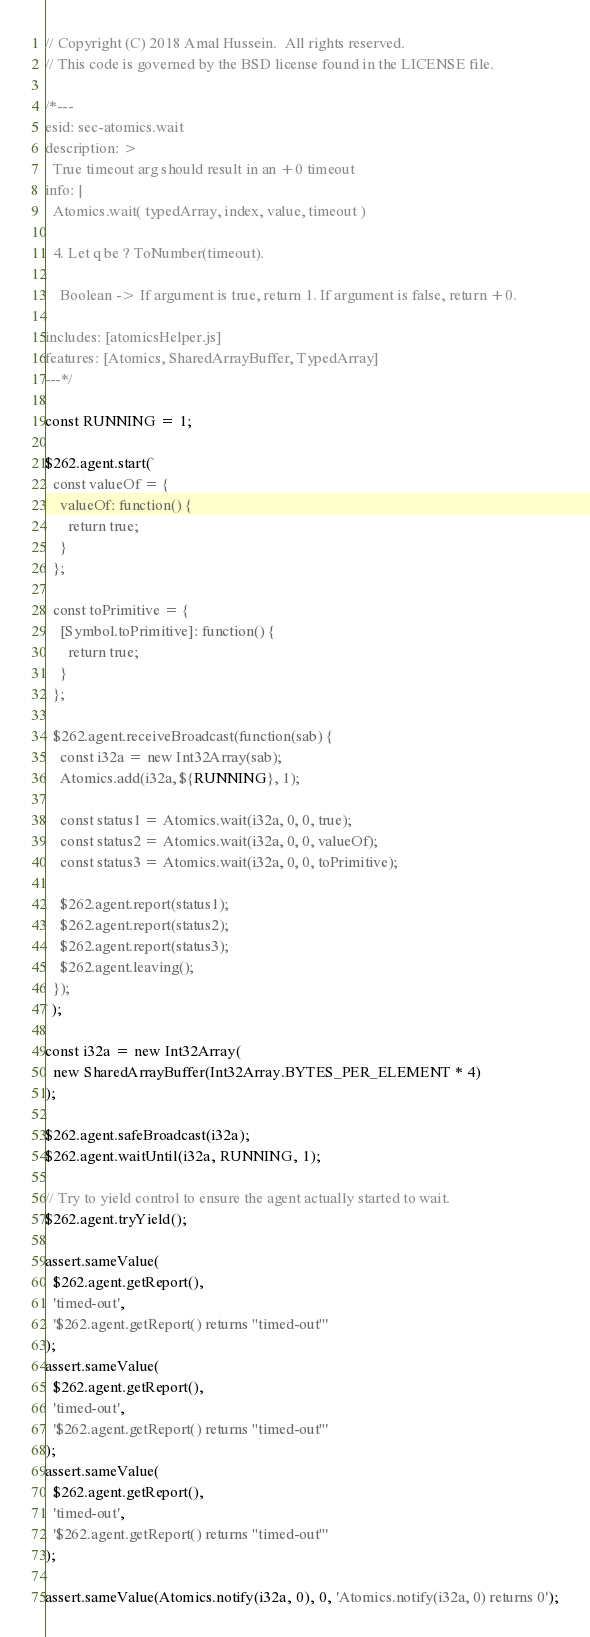Convert code to text. <code><loc_0><loc_0><loc_500><loc_500><_JavaScript_>// Copyright (C) 2018 Amal Hussein.  All rights reserved.
// This code is governed by the BSD license found in the LICENSE file.

/*---
esid: sec-atomics.wait
description: >
  True timeout arg should result in an +0 timeout
info: |
  Atomics.wait( typedArray, index, value, timeout )

  4. Let q be ? ToNumber(timeout).

    Boolean -> If argument is true, return 1. If argument is false, return +0.

includes: [atomicsHelper.js]
features: [Atomics, SharedArrayBuffer, TypedArray]
---*/

const RUNNING = 1;

$262.agent.start(`
  const valueOf = {
    valueOf: function() {
      return true;
    }
  };

  const toPrimitive = {
    [Symbol.toPrimitive]: function() {
      return true;
    }
  };

  $262.agent.receiveBroadcast(function(sab) {
    const i32a = new Int32Array(sab);
    Atomics.add(i32a, ${RUNNING}, 1);

    const status1 = Atomics.wait(i32a, 0, 0, true);
    const status2 = Atomics.wait(i32a, 0, 0, valueOf);
    const status3 = Atomics.wait(i32a, 0, 0, toPrimitive);

    $262.agent.report(status1);
    $262.agent.report(status2);
    $262.agent.report(status3);
    $262.agent.leaving();
  });
`);

const i32a = new Int32Array(
  new SharedArrayBuffer(Int32Array.BYTES_PER_ELEMENT * 4)
);

$262.agent.safeBroadcast(i32a);
$262.agent.waitUntil(i32a, RUNNING, 1);

// Try to yield control to ensure the agent actually started to wait.
$262.agent.tryYield();

assert.sameValue(
  $262.agent.getReport(),
  'timed-out',
  '$262.agent.getReport() returns "timed-out"'
);
assert.sameValue(
  $262.agent.getReport(),
  'timed-out',
  '$262.agent.getReport() returns "timed-out"'
);
assert.sameValue(
  $262.agent.getReport(),
  'timed-out',
  '$262.agent.getReport() returns "timed-out"'
);

assert.sameValue(Atomics.notify(i32a, 0), 0, 'Atomics.notify(i32a, 0) returns 0');
</code> 